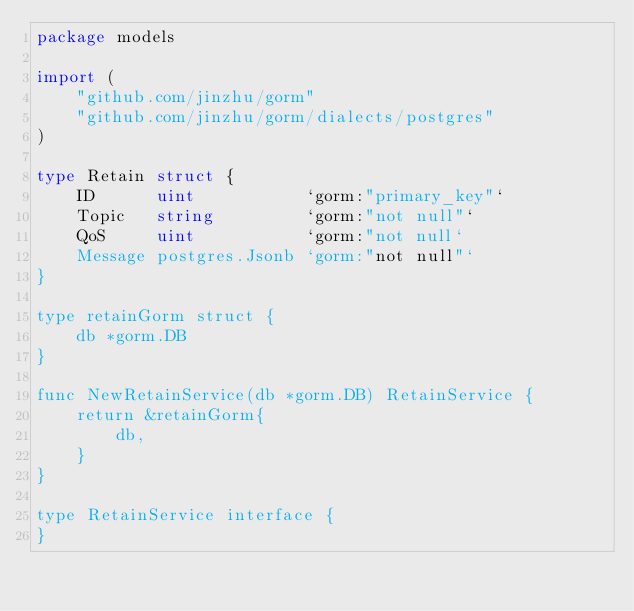Convert code to text. <code><loc_0><loc_0><loc_500><loc_500><_Go_>package models

import (
	"github.com/jinzhu/gorm"
	"github.com/jinzhu/gorm/dialects/postgres"
)

type Retain struct {
	ID      uint           `gorm:"primary_key"`
	Topic   string         `gorm:"not null"`
	QoS     uint           `gorm:"not null`
	Message postgres.Jsonb `gorm:"not null"`
}

type retainGorm struct {
	db *gorm.DB
}

func NewRetainService(db *gorm.DB) RetainService {
	return &retainGorm{
		db,
	}
}

type RetainService interface {
}
</code> 